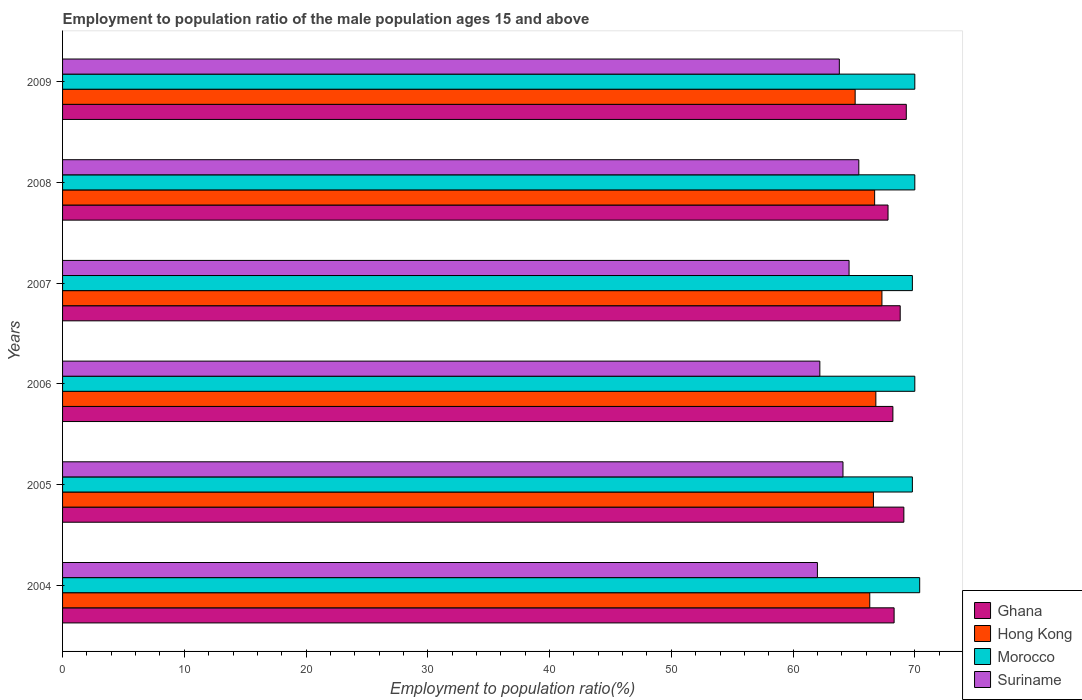How many groups of bars are there?
Offer a terse response. 6. Are the number of bars per tick equal to the number of legend labels?
Keep it short and to the point. Yes. How many bars are there on the 6th tick from the top?
Keep it short and to the point. 4. How many bars are there on the 6th tick from the bottom?
Make the answer very short. 4. What is the employment to population ratio in Ghana in 2005?
Provide a succinct answer. 69.1. Across all years, what is the maximum employment to population ratio in Hong Kong?
Your answer should be compact. 67.3. Across all years, what is the minimum employment to population ratio in Morocco?
Your response must be concise. 69.8. In which year was the employment to population ratio in Suriname minimum?
Keep it short and to the point. 2004. What is the total employment to population ratio in Morocco in the graph?
Your answer should be compact. 420. What is the difference between the employment to population ratio in Suriname in 2004 and that in 2008?
Make the answer very short. -3.4. What is the difference between the employment to population ratio in Morocco in 2004 and the employment to population ratio in Ghana in 2005?
Ensure brevity in your answer.  1.3. What is the average employment to population ratio in Ghana per year?
Give a very brief answer. 68.58. In the year 2007, what is the difference between the employment to population ratio in Morocco and employment to population ratio in Suriname?
Offer a very short reply. 5.2. What is the ratio of the employment to population ratio in Suriname in 2004 to that in 2009?
Your response must be concise. 0.97. Is the difference between the employment to population ratio in Morocco in 2004 and 2005 greater than the difference between the employment to population ratio in Suriname in 2004 and 2005?
Give a very brief answer. Yes. What is the difference between the highest and the second highest employment to population ratio in Morocco?
Offer a terse response. 0.4. What is the difference between the highest and the lowest employment to population ratio in Suriname?
Offer a very short reply. 3.4. Is the sum of the employment to population ratio in Suriname in 2004 and 2006 greater than the maximum employment to population ratio in Hong Kong across all years?
Make the answer very short. Yes. Is it the case that in every year, the sum of the employment to population ratio in Suriname and employment to population ratio in Ghana is greater than the sum of employment to population ratio in Morocco and employment to population ratio in Hong Kong?
Keep it short and to the point. Yes. What does the 1st bar from the top in 2006 represents?
Make the answer very short. Suriname. What does the 4th bar from the bottom in 2008 represents?
Provide a succinct answer. Suriname. Is it the case that in every year, the sum of the employment to population ratio in Morocco and employment to population ratio in Hong Kong is greater than the employment to population ratio in Ghana?
Offer a very short reply. Yes. How many bars are there?
Give a very brief answer. 24. Are all the bars in the graph horizontal?
Ensure brevity in your answer.  Yes. How many years are there in the graph?
Offer a very short reply. 6. What is the difference between two consecutive major ticks on the X-axis?
Your answer should be very brief. 10. Are the values on the major ticks of X-axis written in scientific E-notation?
Your answer should be very brief. No. How are the legend labels stacked?
Ensure brevity in your answer.  Vertical. What is the title of the graph?
Offer a very short reply. Employment to population ratio of the male population ages 15 and above. Does "Benin" appear as one of the legend labels in the graph?
Keep it short and to the point. No. What is the label or title of the Y-axis?
Keep it short and to the point. Years. What is the Employment to population ratio(%) of Ghana in 2004?
Give a very brief answer. 68.3. What is the Employment to population ratio(%) in Hong Kong in 2004?
Offer a terse response. 66.3. What is the Employment to population ratio(%) in Morocco in 2004?
Provide a succinct answer. 70.4. What is the Employment to population ratio(%) in Suriname in 2004?
Offer a very short reply. 62. What is the Employment to population ratio(%) of Ghana in 2005?
Provide a short and direct response. 69.1. What is the Employment to population ratio(%) of Hong Kong in 2005?
Keep it short and to the point. 66.6. What is the Employment to population ratio(%) in Morocco in 2005?
Make the answer very short. 69.8. What is the Employment to population ratio(%) in Suriname in 2005?
Ensure brevity in your answer.  64.1. What is the Employment to population ratio(%) in Ghana in 2006?
Your answer should be very brief. 68.2. What is the Employment to population ratio(%) in Hong Kong in 2006?
Provide a short and direct response. 66.8. What is the Employment to population ratio(%) of Morocco in 2006?
Your answer should be compact. 70. What is the Employment to population ratio(%) of Suriname in 2006?
Provide a succinct answer. 62.2. What is the Employment to population ratio(%) in Ghana in 2007?
Keep it short and to the point. 68.8. What is the Employment to population ratio(%) in Hong Kong in 2007?
Make the answer very short. 67.3. What is the Employment to population ratio(%) of Morocco in 2007?
Make the answer very short. 69.8. What is the Employment to population ratio(%) of Suriname in 2007?
Ensure brevity in your answer.  64.6. What is the Employment to population ratio(%) of Ghana in 2008?
Offer a terse response. 67.8. What is the Employment to population ratio(%) of Hong Kong in 2008?
Make the answer very short. 66.7. What is the Employment to population ratio(%) in Suriname in 2008?
Offer a very short reply. 65.4. What is the Employment to population ratio(%) of Ghana in 2009?
Ensure brevity in your answer.  69.3. What is the Employment to population ratio(%) in Hong Kong in 2009?
Provide a succinct answer. 65.1. What is the Employment to population ratio(%) in Morocco in 2009?
Ensure brevity in your answer.  70. What is the Employment to population ratio(%) in Suriname in 2009?
Your response must be concise. 63.8. Across all years, what is the maximum Employment to population ratio(%) of Ghana?
Keep it short and to the point. 69.3. Across all years, what is the maximum Employment to population ratio(%) in Hong Kong?
Your response must be concise. 67.3. Across all years, what is the maximum Employment to population ratio(%) in Morocco?
Your answer should be very brief. 70.4. Across all years, what is the maximum Employment to population ratio(%) of Suriname?
Your answer should be very brief. 65.4. Across all years, what is the minimum Employment to population ratio(%) of Ghana?
Make the answer very short. 67.8. Across all years, what is the minimum Employment to population ratio(%) of Hong Kong?
Make the answer very short. 65.1. Across all years, what is the minimum Employment to population ratio(%) in Morocco?
Your response must be concise. 69.8. What is the total Employment to population ratio(%) of Ghana in the graph?
Your answer should be compact. 411.5. What is the total Employment to population ratio(%) of Hong Kong in the graph?
Provide a succinct answer. 398.8. What is the total Employment to population ratio(%) of Morocco in the graph?
Make the answer very short. 420. What is the total Employment to population ratio(%) of Suriname in the graph?
Your response must be concise. 382.1. What is the difference between the Employment to population ratio(%) of Hong Kong in 2004 and that in 2006?
Give a very brief answer. -0.5. What is the difference between the Employment to population ratio(%) in Morocco in 2004 and that in 2006?
Provide a succinct answer. 0.4. What is the difference between the Employment to population ratio(%) in Suriname in 2004 and that in 2007?
Offer a very short reply. -2.6. What is the difference between the Employment to population ratio(%) of Ghana in 2004 and that in 2008?
Offer a terse response. 0.5. What is the difference between the Employment to population ratio(%) in Hong Kong in 2004 and that in 2008?
Give a very brief answer. -0.4. What is the difference between the Employment to population ratio(%) of Suriname in 2004 and that in 2008?
Give a very brief answer. -3.4. What is the difference between the Employment to population ratio(%) in Ghana in 2004 and that in 2009?
Your response must be concise. -1. What is the difference between the Employment to population ratio(%) of Hong Kong in 2004 and that in 2009?
Make the answer very short. 1.2. What is the difference between the Employment to population ratio(%) of Ghana in 2005 and that in 2006?
Make the answer very short. 0.9. What is the difference between the Employment to population ratio(%) of Hong Kong in 2005 and that in 2007?
Your response must be concise. -0.7. What is the difference between the Employment to population ratio(%) of Suriname in 2005 and that in 2007?
Keep it short and to the point. -0.5. What is the difference between the Employment to population ratio(%) of Hong Kong in 2005 and that in 2008?
Ensure brevity in your answer.  -0.1. What is the difference between the Employment to population ratio(%) of Morocco in 2005 and that in 2008?
Offer a terse response. -0.2. What is the difference between the Employment to population ratio(%) in Ghana in 2005 and that in 2009?
Your response must be concise. -0.2. What is the difference between the Employment to population ratio(%) in Hong Kong in 2005 and that in 2009?
Offer a very short reply. 1.5. What is the difference between the Employment to population ratio(%) in Morocco in 2005 and that in 2009?
Your response must be concise. -0.2. What is the difference between the Employment to population ratio(%) of Suriname in 2005 and that in 2009?
Your answer should be compact. 0.3. What is the difference between the Employment to population ratio(%) in Hong Kong in 2006 and that in 2007?
Provide a short and direct response. -0.5. What is the difference between the Employment to population ratio(%) in Morocco in 2006 and that in 2007?
Offer a very short reply. 0.2. What is the difference between the Employment to population ratio(%) in Morocco in 2006 and that in 2008?
Offer a very short reply. 0. What is the difference between the Employment to population ratio(%) of Ghana in 2006 and that in 2009?
Keep it short and to the point. -1.1. What is the difference between the Employment to population ratio(%) in Morocco in 2006 and that in 2009?
Give a very brief answer. 0. What is the difference between the Employment to population ratio(%) in Ghana in 2007 and that in 2008?
Your answer should be very brief. 1. What is the difference between the Employment to population ratio(%) in Suriname in 2007 and that in 2008?
Give a very brief answer. -0.8. What is the difference between the Employment to population ratio(%) of Ghana in 2007 and that in 2009?
Provide a short and direct response. -0.5. What is the difference between the Employment to population ratio(%) of Hong Kong in 2007 and that in 2009?
Offer a very short reply. 2.2. What is the difference between the Employment to population ratio(%) of Morocco in 2007 and that in 2009?
Provide a short and direct response. -0.2. What is the difference between the Employment to population ratio(%) in Suriname in 2007 and that in 2009?
Offer a very short reply. 0.8. What is the difference between the Employment to population ratio(%) in Ghana in 2008 and that in 2009?
Make the answer very short. -1.5. What is the difference between the Employment to population ratio(%) in Ghana in 2004 and the Employment to population ratio(%) in Suriname in 2005?
Provide a succinct answer. 4.2. What is the difference between the Employment to population ratio(%) of Hong Kong in 2004 and the Employment to population ratio(%) of Morocco in 2005?
Offer a terse response. -3.5. What is the difference between the Employment to population ratio(%) in Hong Kong in 2004 and the Employment to population ratio(%) in Suriname in 2005?
Make the answer very short. 2.2. What is the difference between the Employment to population ratio(%) in Morocco in 2004 and the Employment to population ratio(%) in Suriname in 2005?
Provide a succinct answer. 6.3. What is the difference between the Employment to population ratio(%) in Ghana in 2004 and the Employment to population ratio(%) in Hong Kong in 2006?
Keep it short and to the point. 1.5. What is the difference between the Employment to population ratio(%) of Ghana in 2004 and the Employment to population ratio(%) of Morocco in 2006?
Your answer should be compact. -1.7. What is the difference between the Employment to population ratio(%) in Ghana in 2004 and the Employment to population ratio(%) in Suriname in 2006?
Your response must be concise. 6.1. What is the difference between the Employment to population ratio(%) in Morocco in 2004 and the Employment to population ratio(%) in Suriname in 2006?
Ensure brevity in your answer.  8.2. What is the difference between the Employment to population ratio(%) in Hong Kong in 2004 and the Employment to population ratio(%) in Morocco in 2007?
Give a very brief answer. -3.5. What is the difference between the Employment to population ratio(%) in Hong Kong in 2004 and the Employment to population ratio(%) in Suriname in 2007?
Provide a succinct answer. 1.7. What is the difference between the Employment to population ratio(%) in Morocco in 2004 and the Employment to population ratio(%) in Suriname in 2007?
Ensure brevity in your answer.  5.8. What is the difference between the Employment to population ratio(%) of Ghana in 2004 and the Employment to population ratio(%) of Hong Kong in 2008?
Provide a short and direct response. 1.6. What is the difference between the Employment to population ratio(%) of Ghana in 2004 and the Employment to population ratio(%) of Morocco in 2008?
Your answer should be very brief. -1.7. What is the difference between the Employment to population ratio(%) in Ghana in 2004 and the Employment to population ratio(%) in Morocco in 2009?
Your response must be concise. -1.7. What is the difference between the Employment to population ratio(%) in Morocco in 2004 and the Employment to population ratio(%) in Suriname in 2009?
Your answer should be very brief. 6.6. What is the difference between the Employment to population ratio(%) in Ghana in 2005 and the Employment to population ratio(%) in Hong Kong in 2006?
Your answer should be very brief. 2.3. What is the difference between the Employment to population ratio(%) in Ghana in 2005 and the Employment to population ratio(%) in Morocco in 2006?
Make the answer very short. -0.9. What is the difference between the Employment to population ratio(%) in Ghana in 2005 and the Employment to population ratio(%) in Suriname in 2006?
Provide a short and direct response. 6.9. What is the difference between the Employment to population ratio(%) in Hong Kong in 2005 and the Employment to population ratio(%) in Suriname in 2006?
Your answer should be very brief. 4.4. What is the difference between the Employment to population ratio(%) in Ghana in 2005 and the Employment to population ratio(%) in Morocco in 2008?
Ensure brevity in your answer.  -0.9. What is the difference between the Employment to population ratio(%) in Ghana in 2005 and the Employment to population ratio(%) in Suriname in 2008?
Ensure brevity in your answer.  3.7. What is the difference between the Employment to population ratio(%) in Hong Kong in 2005 and the Employment to population ratio(%) in Suriname in 2008?
Offer a very short reply. 1.2. What is the difference between the Employment to population ratio(%) in Ghana in 2005 and the Employment to population ratio(%) in Hong Kong in 2009?
Provide a succinct answer. 4. What is the difference between the Employment to population ratio(%) in Ghana in 2005 and the Employment to population ratio(%) in Morocco in 2009?
Your answer should be compact. -0.9. What is the difference between the Employment to population ratio(%) of Hong Kong in 2005 and the Employment to population ratio(%) of Morocco in 2009?
Your response must be concise. -3.4. What is the difference between the Employment to population ratio(%) of Hong Kong in 2005 and the Employment to population ratio(%) of Suriname in 2009?
Keep it short and to the point. 2.8. What is the difference between the Employment to population ratio(%) of Ghana in 2006 and the Employment to population ratio(%) of Hong Kong in 2007?
Offer a very short reply. 0.9. What is the difference between the Employment to population ratio(%) of Ghana in 2006 and the Employment to population ratio(%) of Suriname in 2007?
Your response must be concise. 3.6. What is the difference between the Employment to population ratio(%) in Hong Kong in 2006 and the Employment to population ratio(%) in Morocco in 2007?
Provide a short and direct response. -3. What is the difference between the Employment to population ratio(%) of Hong Kong in 2006 and the Employment to population ratio(%) of Suriname in 2007?
Give a very brief answer. 2.2. What is the difference between the Employment to population ratio(%) of Morocco in 2006 and the Employment to population ratio(%) of Suriname in 2007?
Keep it short and to the point. 5.4. What is the difference between the Employment to population ratio(%) of Ghana in 2006 and the Employment to population ratio(%) of Hong Kong in 2008?
Your answer should be very brief. 1.5. What is the difference between the Employment to population ratio(%) of Hong Kong in 2006 and the Employment to population ratio(%) of Morocco in 2008?
Give a very brief answer. -3.2. What is the difference between the Employment to population ratio(%) of Ghana in 2006 and the Employment to population ratio(%) of Morocco in 2009?
Your answer should be compact. -1.8. What is the difference between the Employment to population ratio(%) of Hong Kong in 2006 and the Employment to population ratio(%) of Suriname in 2009?
Keep it short and to the point. 3. What is the difference between the Employment to population ratio(%) of Hong Kong in 2007 and the Employment to population ratio(%) of Morocco in 2008?
Ensure brevity in your answer.  -2.7. What is the difference between the Employment to population ratio(%) of Ghana in 2007 and the Employment to population ratio(%) of Morocco in 2009?
Give a very brief answer. -1.2. What is the difference between the Employment to population ratio(%) of Hong Kong in 2007 and the Employment to population ratio(%) of Morocco in 2009?
Give a very brief answer. -2.7. What is the difference between the Employment to population ratio(%) in Hong Kong in 2007 and the Employment to population ratio(%) in Suriname in 2009?
Offer a terse response. 3.5. What is the difference between the Employment to population ratio(%) in Morocco in 2007 and the Employment to population ratio(%) in Suriname in 2009?
Provide a succinct answer. 6. What is the difference between the Employment to population ratio(%) in Ghana in 2008 and the Employment to population ratio(%) in Hong Kong in 2009?
Ensure brevity in your answer.  2.7. What is the difference between the Employment to population ratio(%) of Hong Kong in 2008 and the Employment to population ratio(%) of Morocco in 2009?
Keep it short and to the point. -3.3. What is the difference between the Employment to population ratio(%) in Morocco in 2008 and the Employment to population ratio(%) in Suriname in 2009?
Keep it short and to the point. 6.2. What is the average Employment to population ratio(%) in Ghana per year?
Make the answer very short. 68.58. What is the average Employment to population ratio(%) in Hong Kong per year?
Keep it short and to the point. 66.47. What is the average Employment to population ratio(%) of Morocco per year?
Make the answer very short. 70. What is the average Employment to population ratio(%) in Suriname per year?
Provide a succinct answer. 63.68. In the year 2004, what is the difference between the Employment to population ratio(%) of Ghana and Employment to population ratio(%) of Hong Kong?
Provide a succinct answer. 2. In the year 2004, what is the difference between the Employment to population ratio(%) of Ghana and Employment to population ratio(%) of Morocco?
Your response must be concise. -2.1. In the year 2004, what is the difference between the Employment to population ratio(%) of Hong Kong and Employment to population ratio(%) of Morocco?
Offer a terse response. -4.1. In the year 2004, what is the difference between the Employment to population ratio(%) in Hong Kong and Employment to population ratio(%) in Suriname?
Ensure brevity in your answer.  4.3. In the year 2004, what is the difference between the Employment to population ratio(%) in Morocco and Employment to population ratio(%) in Suriname?
Offer a very short reply. 8.4. In the year 2005, what is the difference between the Employment to population ratio(%) of Ghana and Employment to population ratio(%) of Hong Kong?
Provide a short and direct response. 2.5. In the year 2005, what is the difference between the Employment to population ratio(%) of Ghana and Employment to population ratio(%) of Morocco?
Keep it short and to the point. -0.7. In the year 2005, what is the difference between the Employment to population ratio(%) of Hong Kong and Employment to population ratio(%) of Morocco?
Your response must be concise. -3.2. In the year 2006, what is the difference between the Employment to population ratio(%) of Ghana and Employment to population ratio(%) of Hong Kong?
Offer a terse response. 1.4. In the year 2007, what is the difference between the Employment to population ratio(%) of Ghana and Employment to population ratio(%) of Hong Kong?
Keep it short and to the point. 1.5. In the year 2007, what is the difference between the Employment to population ratio(%) of Ghana and Employment to population ratio(%) of Morocco?
Your response must be concise. -1. In the year 2008, what is the difference between the Employment to population ratio(%) in Ghana and Employment to population ratio(%) in Hong Kong?
Your answer should be very brief. 1.1. In the year 2008, what is the difference between the Employment to population ratio(%) in Hong Kong and Employment to population ratio(%) in Morocco?
Offer a terse response. -3.3. In the year 2008, what is the difference between the Employment to population ratio(%) in Hong Kong and Employment to population ratio(%) in Suriname?
Give a very brief answer. 1.3. In the year 2008, what is the difference between the Employment to population ratio(%) of Morocco and Employment to population ratio(%) of Suriname?
Keep it short and to the point. 4.6. In the year 2009, what is the difference between the Employment to population ratio(%) of Ghana and Employment to population ratio(%) of Hong Kong?
Keep it short and to the point. 4.2. In the year 2009, what is the difference between the Employment to population ratio(%) in Ghana and Employment to population ratio(%) in Morocco?
Provide a succinct answer. -0.7. In the year 2009, what is the difference between the Employment to population ratio(%) of Ghana and Employment to population ratio(%) of Suriname?
Your answer should be compact. 5.5. In the year 2009, what is the difference between the Employment to population ratio(%) in Hong Kong and Employment to population ratio(%) in Morocco?
Make the answer very short. -4.9. In the year 2009, what is the difference between the Employment to population ratio(%) of Hong Kong and Employment to population ratio(%) of Suriname?
Provide a short and direct response. 1.3. In the year 2009, what is the difference between the Employment to population ratio(%) in Morocco and Employment to population ratio(%) in Suriname?
Keep it short and to the point. 6.2. What is the ratio of the Employment to population ratio(%) in Ghana in 2004 to that in 2005?
Your answer should be compact. 0.99. What is the ratio of the Employment to population ratio(%) of Hong Kong in 2004 to that in 2005?
Your answer should be compact. 1. What is the ratio of the Employment to population ratio(%) in Morocco in 2004 to that in 2005?
Offer a terse response. 1.01. What is the ratio of the Employment to population ratio(%) of Suriname in 2004 to that in 2005?
Ensure brevity in your answer.  0.97. What is the ratio of the Employment to population ratio(%) of Hong Kong in 2004 to that in 2006?
Ensure brevity in your answer.  0.99. What is the ratio of the Employment to population ratio(%) in Morocco in 2004 to that in 2006?
Provide a short and direct response. 1.01. What is the ratio of the Employment to population ratio(%) of Ghana in 2004 to that in 2007?
Offer a very short reply. 0.99. What is the ratio of the Employment to population ratio(%) of Hong Kong in 2004 to that in 2007?
Provide a short and direct response. 0.99. What is the ratio of the Employment to population ratio(%) of Morocco in 2004 to that in 2007?
Ensure brevity in your answer.  1.01. What is the ratio of the Employment to population ratio(%) in Suriname in 2004 to that in 2007?
Your answer should be very brief. 0.96. What is the ratio of the Employment to population ratio(%) of Ghana in 2004 to that in 2008?
Offer a very short reply. 1.01. What is the ratio of the Employment to population ratio(%) of Hong Kong in 2004 to that in 2008?
Offer a terse response. 0.99. What is the ratio of the Employment to population ratio(%) in Morocco in 2004 to that in 2008?
Your answer should be compact. 1.01. What is the ratio of the Employment to population ratio(%) of Suriname in 2004 to that in 2008?
Your response must be concise. 0.95. What is the ratio of the Employment to population ratio(%) in Ghana in 2004 to that in 2009?
Your response must be concise. 0.99. What is the ratio of the Employment to population ratio(%) of Hong Kong in 2004 to that in 2009?
Keep it short and to the point. 1.02. What is the ratio of the Employment to population ratio(%) in Morocco in 2004 to that in 2009?
Provide a short and direct response. 1.01. What is the ratio of the Employment to population ratio(%) of Suriname in 2004 to that in 2009?
Give a very brief answer. 0.97. What is the ratio of the Employment to population ratio(%) in Ghana in 2005 to that in 2006?
Keep it short and to the point. 1.01. What is the ratio of the Employment to population ratio(%) of Suriname in 2005 to that in 2006?
Your response must be concise. 1.03. What is the ratio of the Employment to population ratio(%) in Ghana in 2005 to that in 2007?
Ensure brevity in your answer.  1. What is the ratio of the Employment to population ratio(%) of Hong Kong in 2005 to that in 2007?
Your answer should be very brief. 0.99. What is the ratio of the Employment to population ratio(%) of Ghana in 2005 to that in 2008?
Your response must be concise. 1.02. What is the ratio of the Employment to population ratio(%) of Morocco in 2005 to that in 2008?
Your answer should be compact. 1. What is the ratio of the Employment to population ratio(%) of Suriname in 2005 to that in 2008?
Your answer should be compact. 0.98. What is the ratio of the Employment to population ratio(%) of Ghana in 2005 to that in 2009?
Make the answer very short. 1. What is the ratio of the Employment to population ratio(%) of Hong Kong in 2005 to that in 2009?
Provide a short and direct response. 1.02. What is the ratio of the Employment to population ratio(%) of Morocco in 2005 to that in 2009?
Make the answer very short. 1. What is the ratio of the Employment to population ratio(%) of Suriname in 2005 to that in 2009?
Provide a succinct answer. 1. What is the ratio of the Employment to population ratio(%) in Ghana in 2006 to that in 2007?
Provide a short and direct response. 0.99. What is the ratio of the Employment to population ratio(%) of Morocco in 2006 to that in 2007?
Offer a very short reply. 1. What is the ratio of the Employment to population ratio(%) of Suriname in 2006 to that in 2007?
Ensure brevity in your answer.  0.96. What is the ratio of the Employment to population ratio(%) of Ghana in 2006 to that in 2008?
Provide a succinct answer. 1.01. What is the ratio of the Employment to population ratio(%) in Morocco in 2006 to that in 2008?
Give a very brief answer. 1. What is the ratio of the Employment to population ratio(%) of Suriname in 2006 to that in 2008?
Make the answer very short. 0.95. What is the ratio of the Employment to population ratio(%) of Ghana in 2006 to that in 2009?
Make the answer very short. 0.98. What is the ratio of the Employment to population ratio(%) in Hong Kong in 2006 to that in 2009?
Offer a terse response. 1.03. What is the ratio of the Employment to population ratio(%) in Morocco in 2006 to that in 2009?
Keep it short and to the point. 1. What is the ratio of the Employment to population ratio(%) of Suriname in 2006 to that in 2009?
Give a very brief answer. 0.97. What is the ratio of the Employment to population ratio(%) of Ghana in 2007 to that in 2008?
Keep it short and to the point. 1.01. What is the ratio of the Employment to population ratio(%) in Hong Kong in 2007 to that in 2008?
Your answer should be compact. 1.01. What is the ratio of the Employment to population ratio(%) in Suriname in 2007 to that in 2008?
Your response must be concise. 0.99. What is the ratio of the Employment to population ratio(%) in Ghana in 2007 to that in 2009?
Keep it short and to the point. 0.99. What is the ratio of the Employment to population ratio(%) in Hong Kong in 2007 to that in 2009?
Offer a terse response. 1.03. What is the ratio of the Employment to population ratio(%) of Morocco in 2007 to that in 2009?
Provide a succinct answer. 1. What is the ratio of the Employment to population ratio(%) of Suriname in 2007 to that in 2009?
Ensure brevity in your answer.  1.01. What is the ratio of the Employment to population ratio(%) of Ghana in 2008 to that in 2009?
Provide a short and direct response. 0.98. What is the ratio of the Employment to population ratio(%) in Hong Kong in 2008 to that in 2009?
Your answer should be compact. 1.02. What is the ratio of the Employment to population ratio(%) in Morocco in 2008 to that in 2009?
Your answer should be compact. 1. What is the ratio of the Employment to population ratio(%) of Suriname in 2008 to that in 2009?
Your answer should be very brief. 1.03. What is the difference between the highest and the second highest Employment to population ratio(%) of Hong Kong?
Keep it short and to the point. 0.5. What is the difference between the highest and the second highest Employment to population ratio(%) in Morocco?
Your answer should be compact. 0.4. What is the difference between the highest and the second highest Employment to population ratio(%) of Suriname?
Give a very brief answer. 0.8. What is the difference between the highest and the lowest Employment to population ratio(%) in Ghana?
Ensure brevity in your answer.  1.5. What is the difference between the highest and the lowest Employment to population ratio(%) of Hong Kong?
Your answer should be compact. 2.2. What is the difference between the highest and the lowest Employment to population ratio(%) in Morocco?
Keep it short and to the point. 0.6. What is the difference between the highest and the lowest Employment to population ratio(%) in Suriname?
Offer a very short reply. 3.4. 